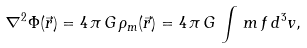Convert formula to latex. <formula><loc_0><loc_0><loc_500><loc_500>\nabla ^ { 2 } \Phi ( \vec { r } ) = 4 \, \pi \, G \, \rho _ { m } ( \vec { r } ) = 4 \, \pi \, G \, \int \, m \, f \, d ^ { 3 } v ,</formula> 